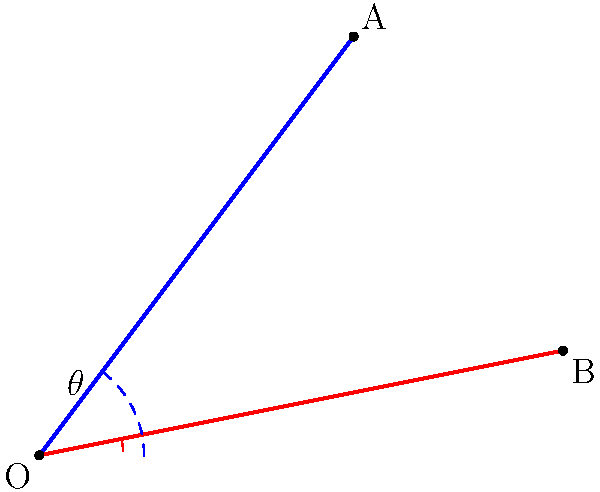During a tennis match, you serve two consecutive balls. The first ball follows the path OA, while the second ball follows the path OB. If the coordinates of point A are (3, 4) and the coordinates of point B are (5, 1), what is the angle $\theta$ between these two serve paths? To find the angle between two lines, we can use the dot product formula:

$\cos \theta = \frac{\vec{a} \cdot \vec{b}}{|\vec{a}||\vec{b}|}$

Where $\vec{a}$ and $\vec{b}$ are vectors representing the two lines.

Step 1: Determine the vectors
$\vec{a} = (3, 4)$
$\vec{b} = (5, 1)$

Step 2: Calculate the dot product $\vec{a} \cdot \vec{b}$
$\vec{a} \cdot \vec{b} = (3)(5) + (4)(1) = 15 + 4 = 19$

Step 3: Calculate the magnitudes of the vectors
$|\vec{a}| = \sqrt{3^2 + 4^2} = \sqrt{9 + 16} = \sqrt{25} = 5$
$|\vec{b}| = \sqrt{5^2 + 1^2} = \sqrt{25 + 1} = \sqrt{26}$

Step 4: Apply the dot product formula
$\cos \theta = \frac{19}{5\sqrt{26}}$

Step 5: Take the inverse cosine (arccos) of both sides
$\theta = \arccos(\frac{19}{5\sqrt{26}})$

Step 6: Calculate the result
$\theta \approx 0.5536$ radians

Step 7: Convert to degrees
$\theta \approx 0.5536 \times \frac{180}{\pi} \approx 31.7°$
Answer: $31.7°$ 